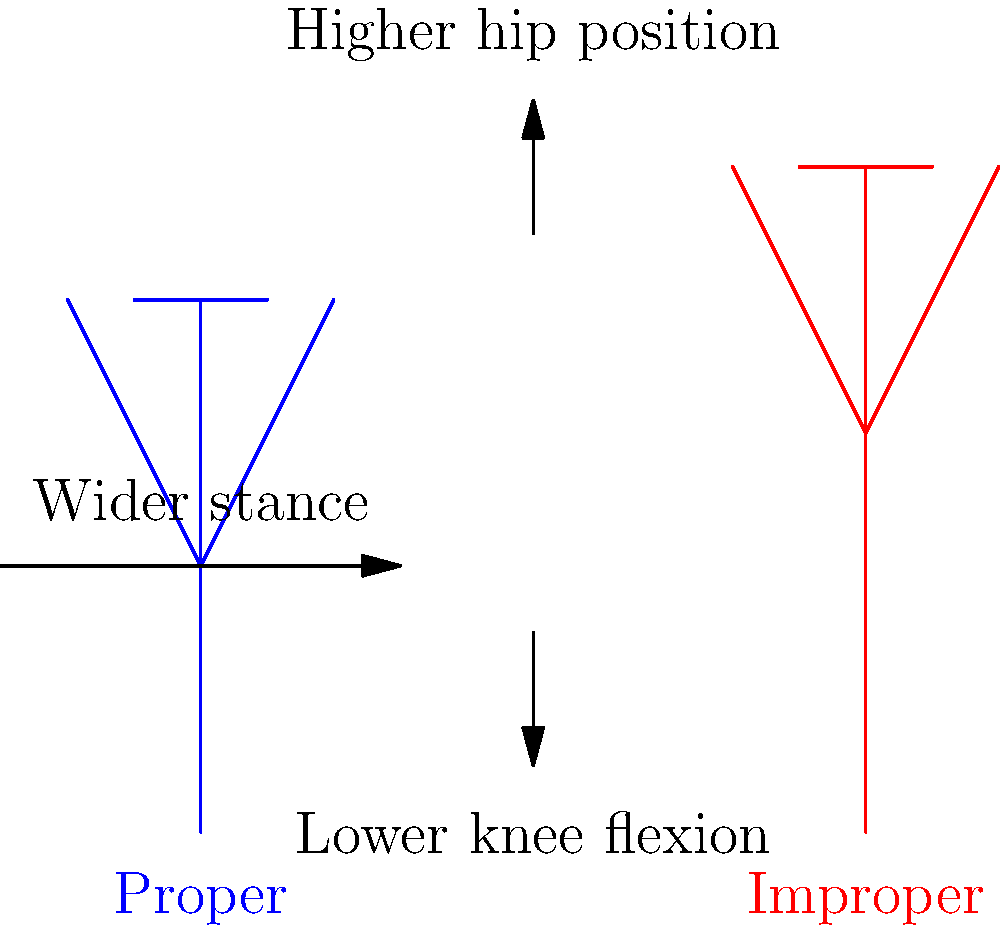As a sports coach, you're analyzing the biomechanics of a proper squat versus an improper squat. Based on the stick figure diagrams, what are the three key biomechanical differences between the proper (blue) and improper (red) squat techniques, and how might these differences impact an athlete's performance and risk of injury? Let's analyze the biomechanical differences between the proper and improper squat techniques:

1. Hip position:
   - Proper squat: The hips are lower, creating a more acute angle at the hip joint.
   - Improper squat: The hips are higher, resulting in a less acute angle at the hip joint.
   - Impact: A lower hip position in the proper squat allows for greater engagement of the gluteal muscles and hamstrings, leading to more power generation and reduced stress on the lower back.

2. Knee flexion:
   - Proper squat: There's a greater degree of knee flexion, with the knees bending more.
   - Improper squat: Less knee flexion is observed, with the knees remaining straighter.
   - Impact: Proper knee flexion distributes the load more evenly across the knee joint and quadriceps, reducing the risk of patellofemoral pain and allowing for greater force production.

3. Stance width:
   - Proper squat: The feet are positioned wider apart.
   - Improper squat: The feet are closer together.
   - Impact: A wider stance in the proper squat provides better stability, engages more muscle groups (including the adductors), and allows for a more natural alignment of the knees over the toes, reducing the risk of knee valgus.

These biomechanical differences significantly impact an athlete's performance and injury risk:

1. Power generation: The proper squat technique allows for greater power output due to increased muscle engagement and optimal joint angles.
2. Injury prevention: The proper technique reduces stress on the lower back, knees, and ankles, lowering the risk of both acute and chronic injuries.
3. Muscle activation: The proper squat engages more muscle groups more effectively, leading to better overall strength development and athletic performance.
4. Balance and stability: The wider stance and lower hip position in the proper squat provide better balance, which is crucial for many sports-specific movements.
Answer: Lower hip position, greater knee flexion, and wider stance in proper squat technique lead to improved power generation, reduced injury risk, and better overall athletic performance. 